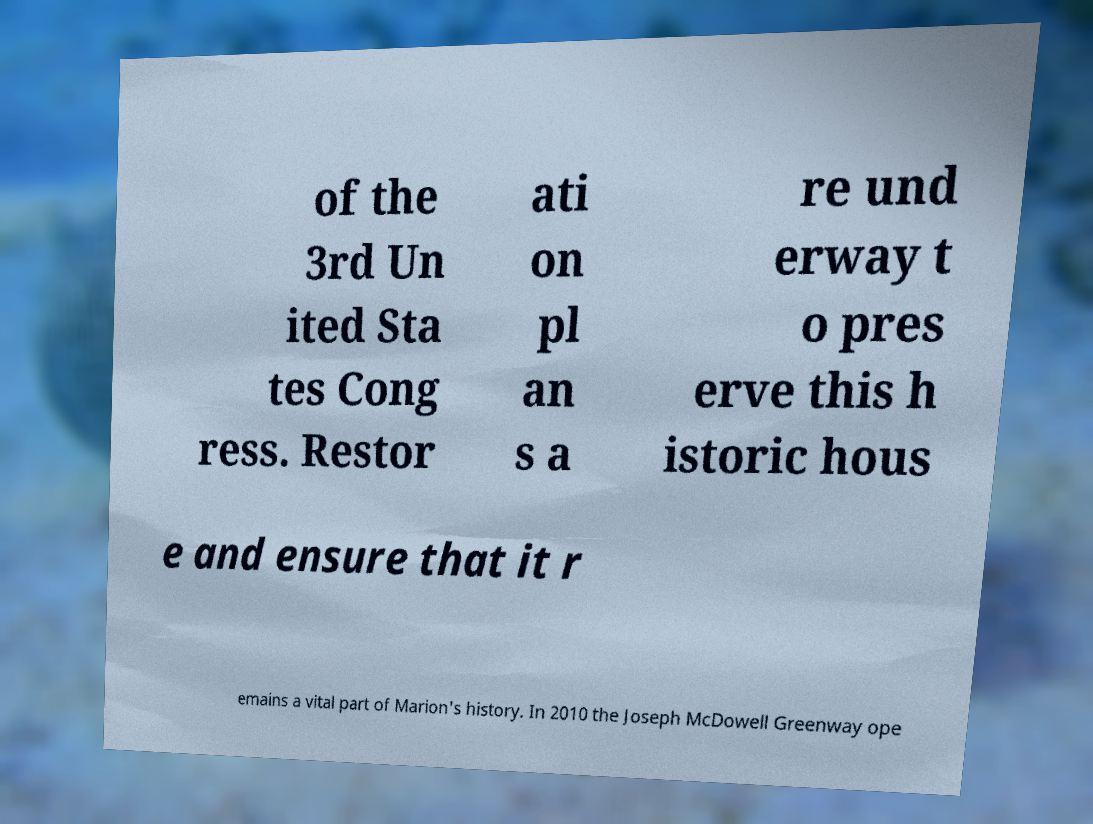What messages or text are displayed in this image? I need them in a readable, typed format. of the 3rd Un ited Sta tes Cong ress. Restor ati on pl an s a re und erway t o pres erve this h istoric hous e and ensure that it r emains a vital part of Marion's history. In 2010 the Joseph McDowell Greenway ope 